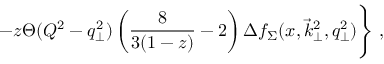Convert formula to latex. <formula><loc_0><loc_0><loc_500><loc_500>- z \Theta ( Q ^ { 2 } - q _ { \perp } ^ { 2 } ) \left ( { \frac { 8 } { 3 ( 1 - z ) } } - 2 \right ) \Delta f _ { \Sigma } ( x , \vec { k } _ { \perp } ^ { 2 } , q _ { \perp } ^ { 2 } ) \Big \} \, ,</formula> 